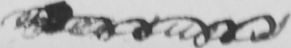Transcribe the text shown in this historical manuscript line. <gap/> 